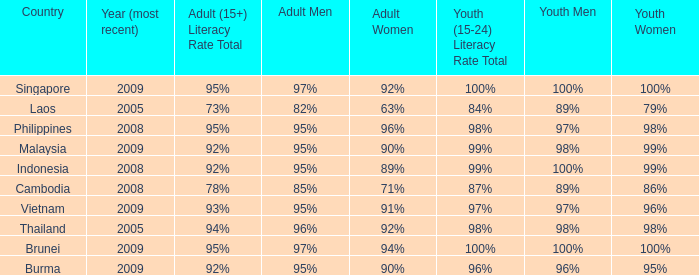What country has a Youth (15-24) Literacy Rate Total of 99%, and a Youth Men of 98%? Malaysia. 